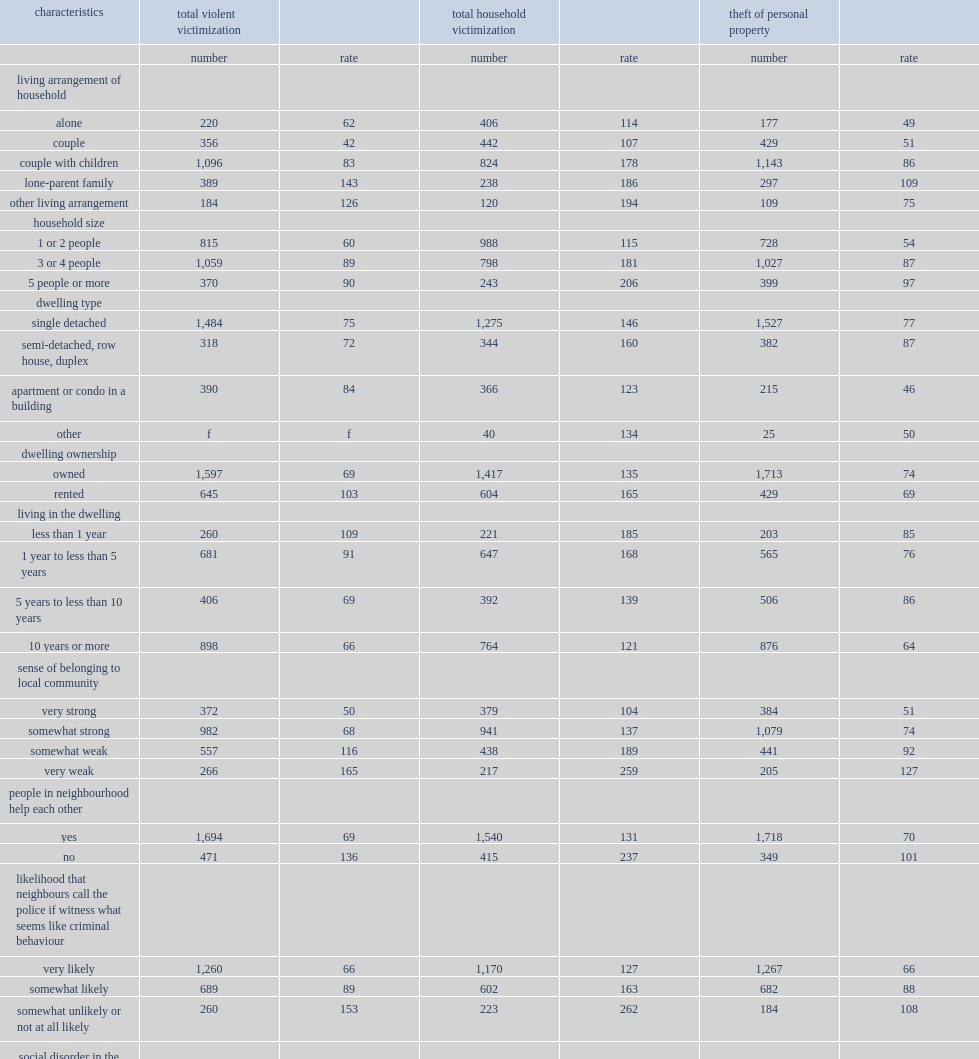Which group has a higher rate of violent victimization, people who have social disorder in the neighbourhood or not? Yes. 